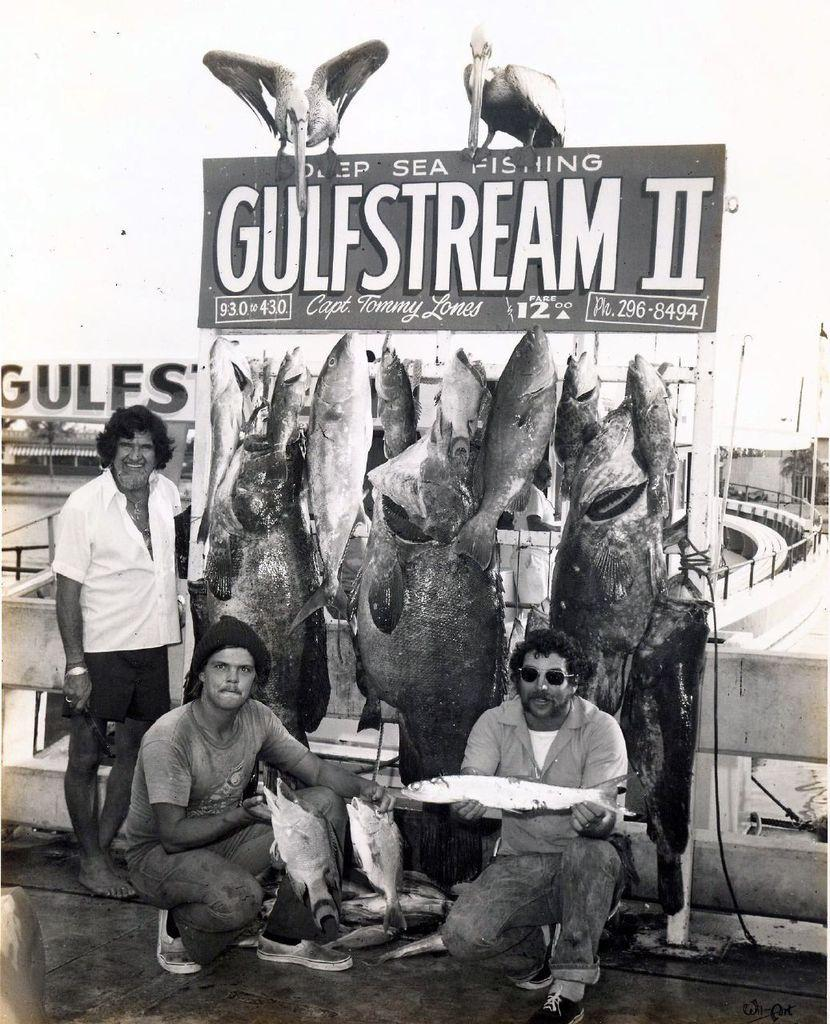How many people are in the image? There are two persons in the image. What are the two persons holding in their hands? The two persons are holding fishes in their hands. Are there any other fishes visible in the image? Yes, there are additional fishes visible in the image. Is there anyone else present in the image besides the two persons holding fishes? Yes, there is a person standing behind the two persons holding fishes. Can you see any cherries in the image? There are no cherries visible in the image. Is there a river flowing in the background of the image? There is no river visible in the image. 